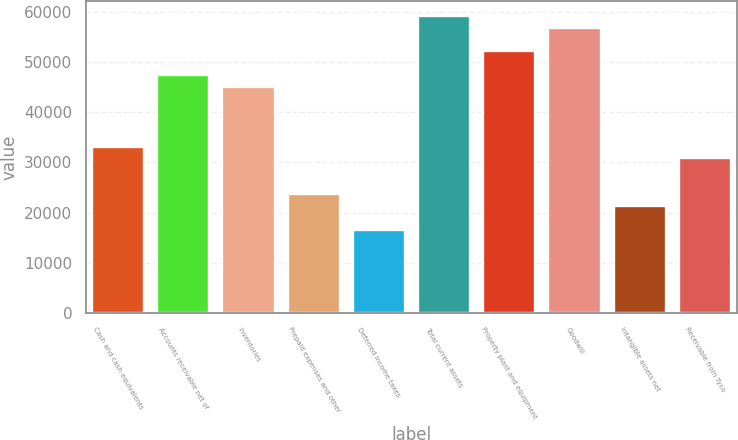Convert chart. <chart><loc_0><loc_0><loc_500><loc_500><bar_chart><fcel>Cash and cash equivalents<fcel>Accounts receivable net of<fcel>Inventories<fcel>Prepaid expenses and other<fcel>Deferred income taxes<fcel>Total current assets<fcel>Property plant and equipment<fcel>Goodwill<fcel>Intangible assets net<fcel>Receivable from Tyco<nl><fcel>33162.4<fcel>47374<fcel>45005.4<fcel>23688<fcel>16582.2<fcel>59217<fcel>52111.2<fcel>56848.4<fcel>21319.4<fcel>30793.8<nl></chart> 